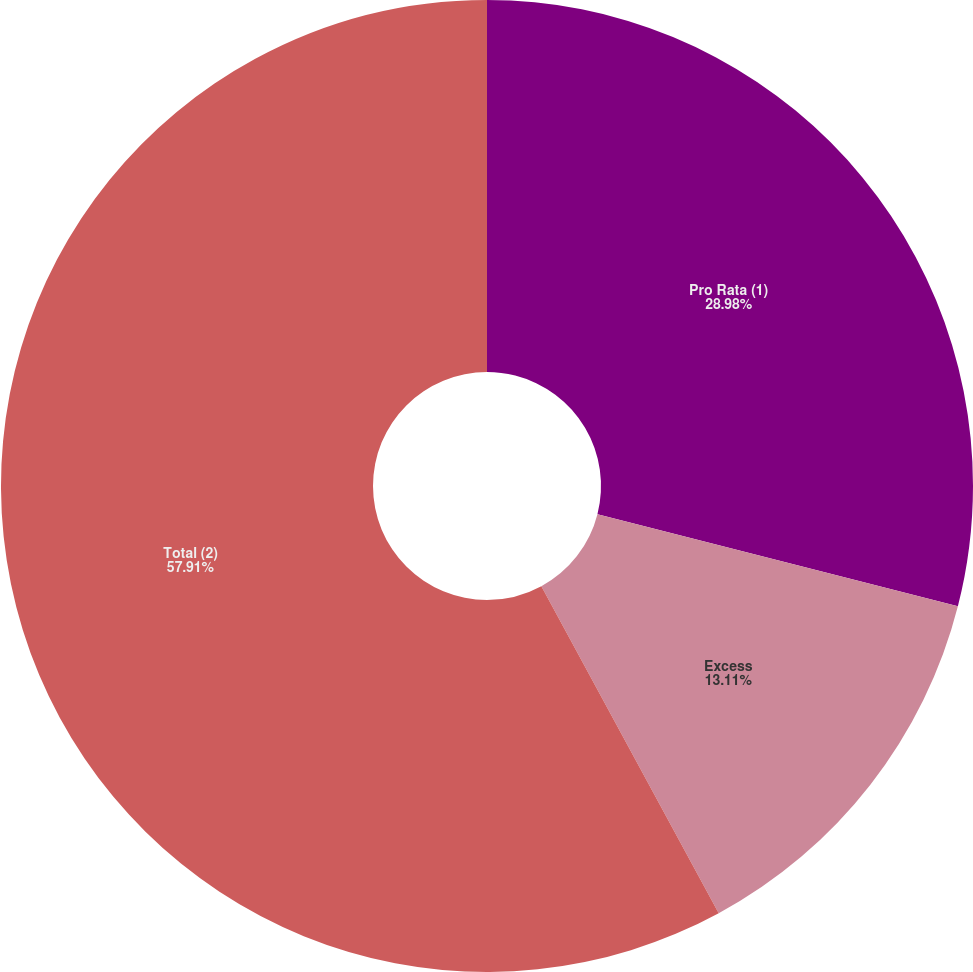<chart> <loc_0><loc_0><loc_500><loc_500><pie_chart><fcel>Pro Rata (1)<fcel>Excess<fcel>Total (2)<nl><fcel>28.98%<fcel>13.11%<fcel>57.91%<nl></chart> 